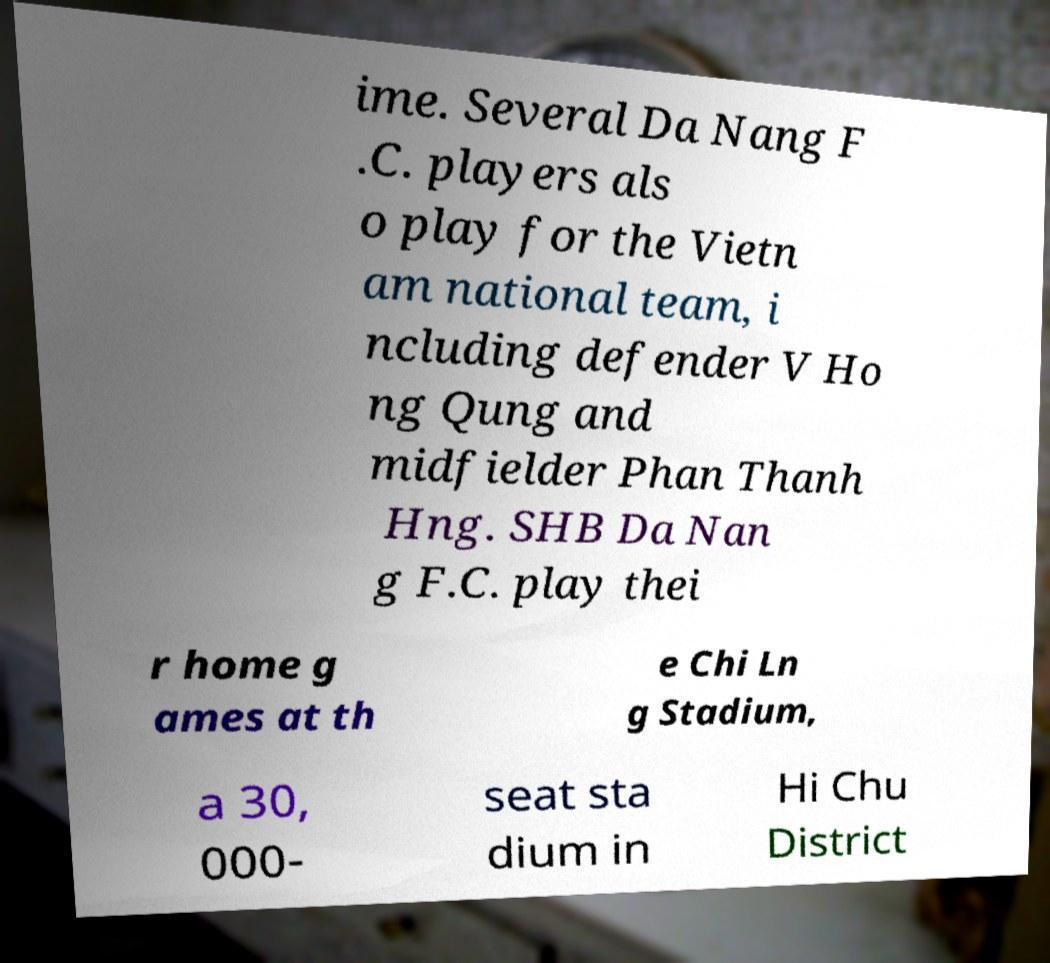Could you extract and type out the text from this image? ime. Several Da Nang F .C. players als o play for the Vietn am national team, i ncluding defender V Ho ng Qung and midfielder Phan Thanh Hng. SHB Da Nan g F.C. play thei r home g ames at th e Chi Ln g Stadium, a 30, 000- seat sta dium in Hi Chu District 